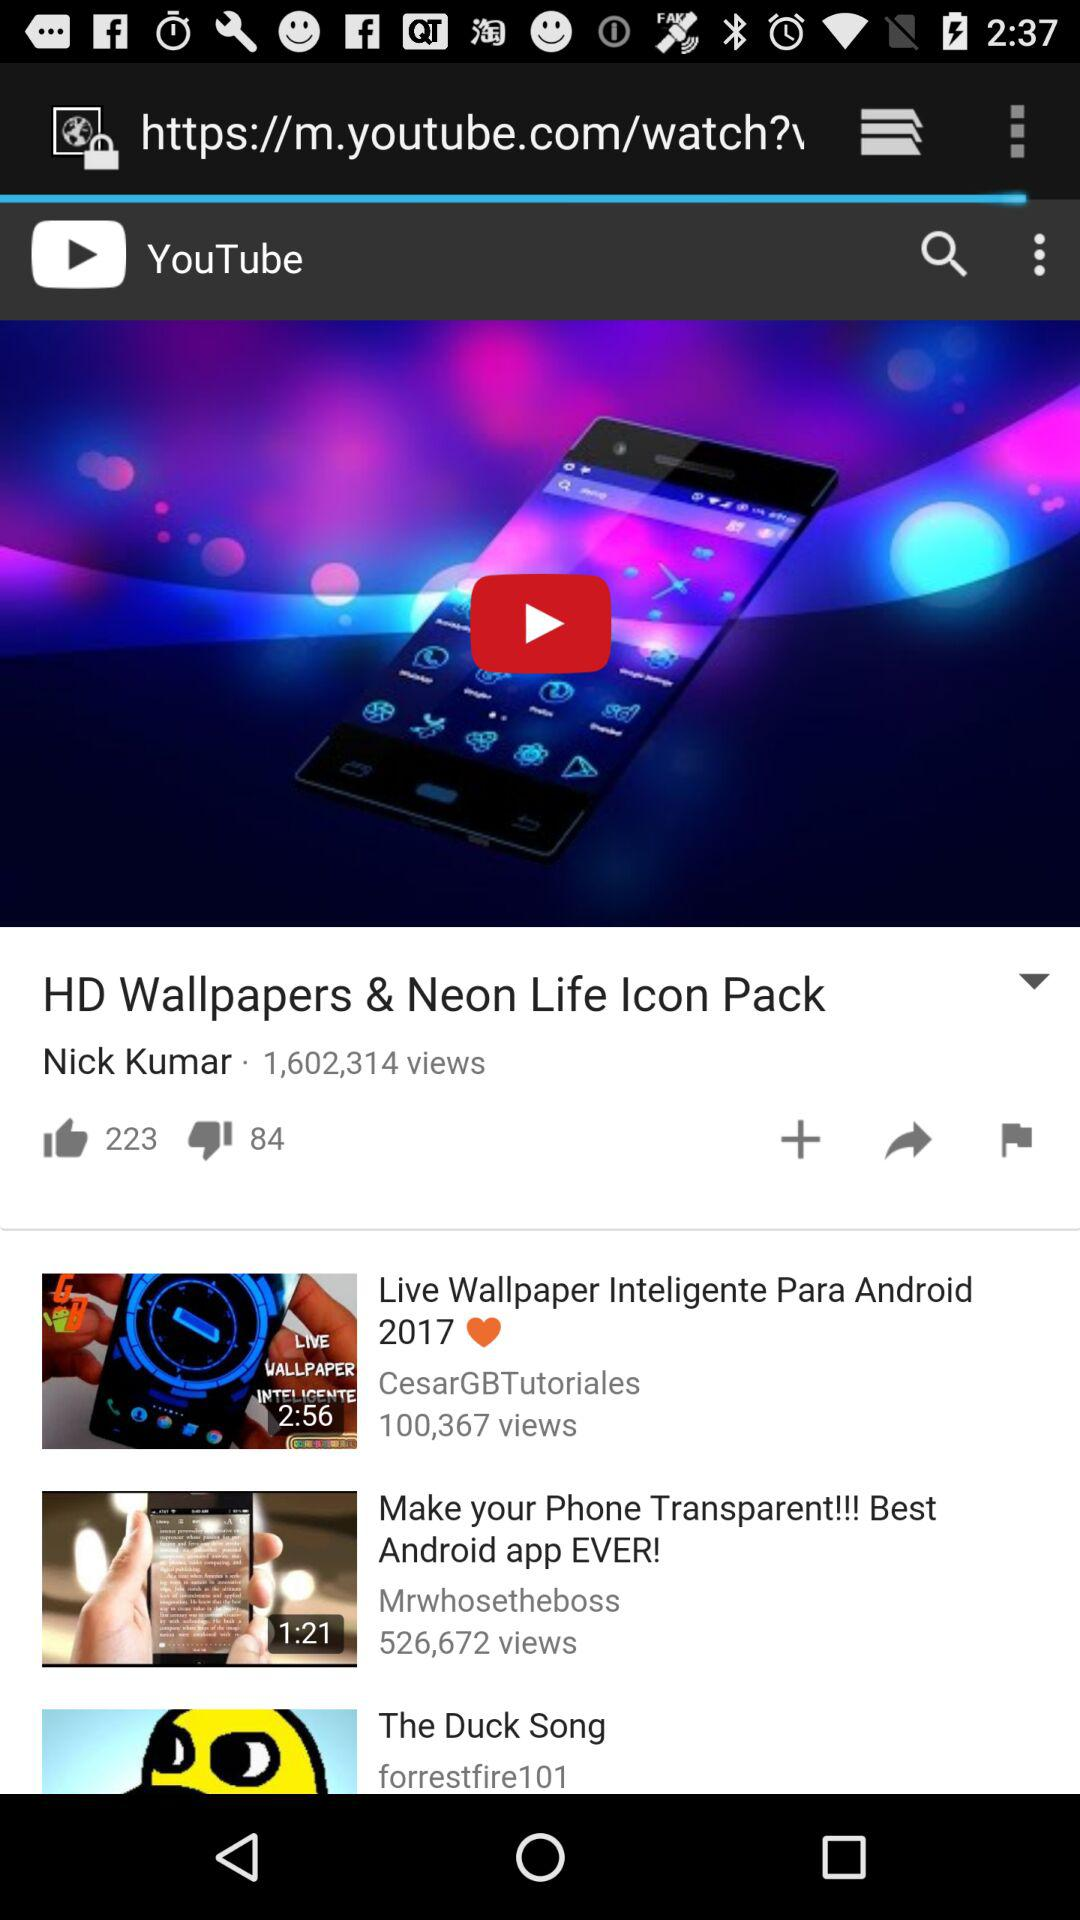Can we share video?
When the provided information is insufficient, respond with <no answer>. <no answer> 